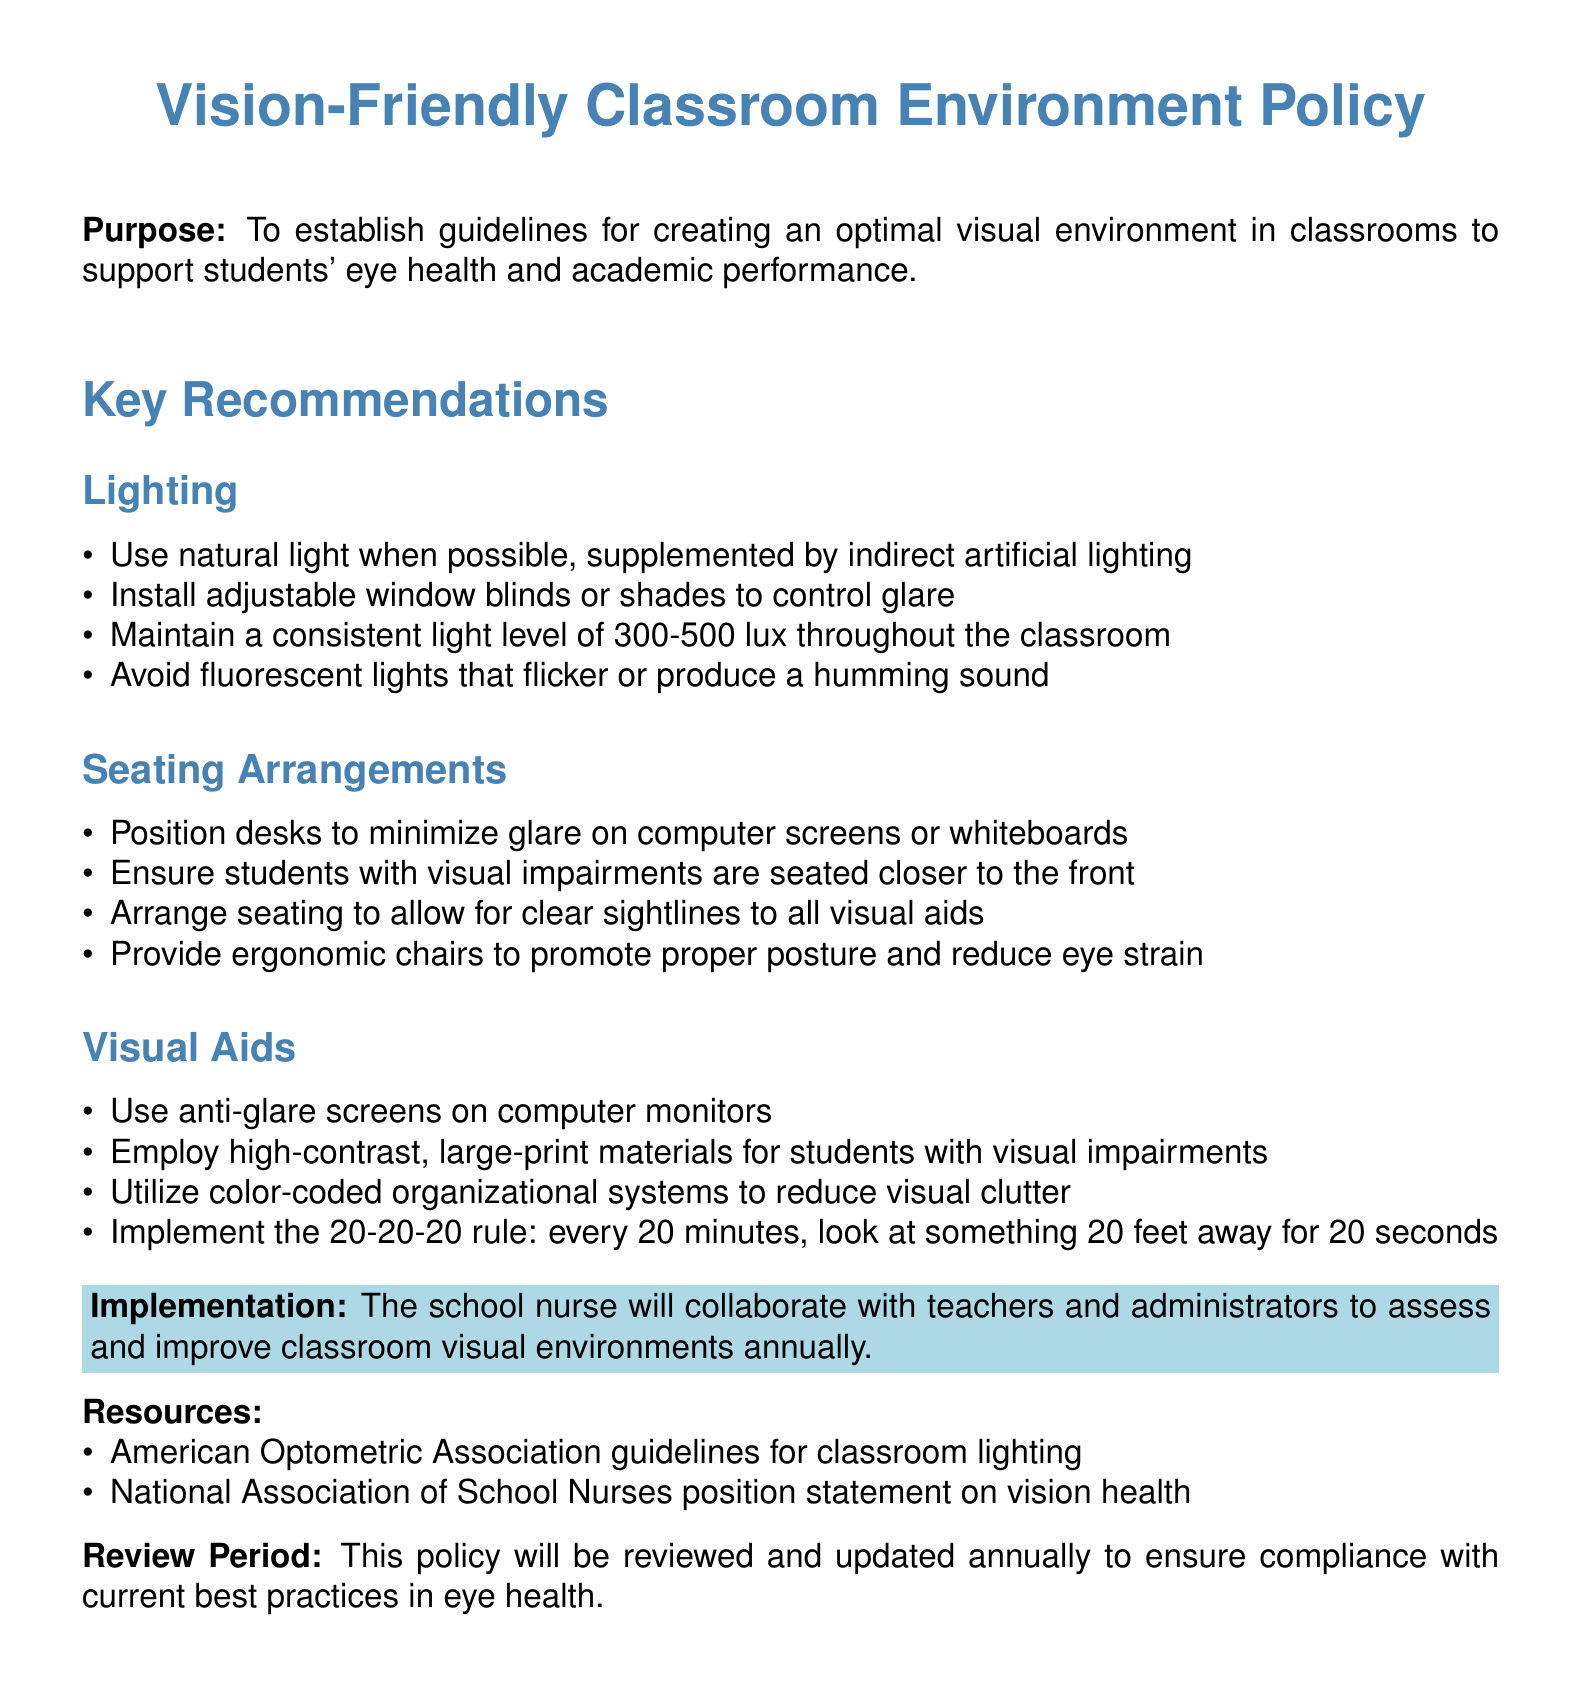What is the purpose of the policy? The purpose of the policy is to establish guidelines for creating an optimal visual environment in classrooms to support students' eye health and academic performance.
Answer: To establish guidelines for creating an optimal visual environment What is the recommended light level for classrooms? The document specifies maintaining a consistent light level of 300-500 lux throughout the classroom.
Answer: 300-500 lux Which type of lights should be avoided? The document advises avoiding fluorescent lights that flicker or produce a humming sound.
Answer: Fluorescent lights What arrangement is suggested for students with visual impairments? The policy recommends that students with visual impairments are seated closer to the front.
Answer: Closer to the front What is the 20-20-20 rule about? The 20-20-20 rule involves looking at something 20 feet away for 20 seconds every 20 minutes.
Answer: Look at something 20 feet away for 20 seconds Who will collaborate to improve classroom visual environments? The school nurse will collaborate with teachers and administrators for this purpose.
Answer: The school nurse What will be reviewed and updated annually? The document states that the policy will be reviewed and updated annually to ensure compliance with current best practices in eye health.
Answer: The policy What type of aids should be used on computer monitors? The document recommends using anti-glare screens on computer monitors.
Answer: Anti-glare screens What type of materials is suggested for students with visual impairments? The policy suggests employing high-contrast, large-print materials for students with visual impairments.
Answer: High-contrast, large-print materials 